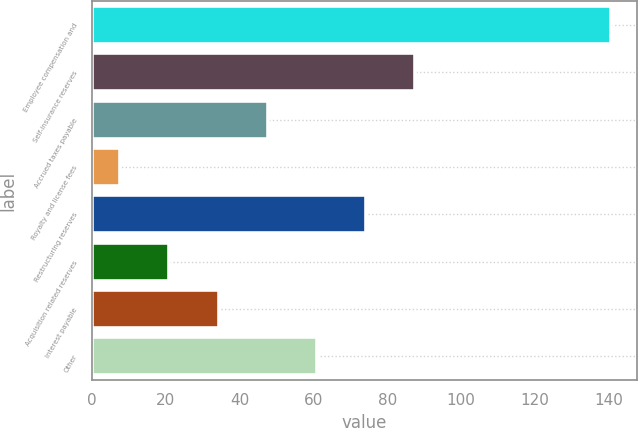Convert chart. <chart><loc_0><loc_0><loc_500><loc_500><bar_chart><fcel>Employee compensation and<fcel>Self-insurance reserves<fcel>Accrued taxes payable<fcel>Royalty and license fees<fcel>Restructuring reserves<fcel>Acquisition related reserves<fcel>Interest payable<fcel>Other<nl><fcel>140.7<fcel>87.5<fcel>47.6<fcel>7.7<fcel>74.2<fcel>21<fcel>34.3<fcel>60.9<nl></chart> 